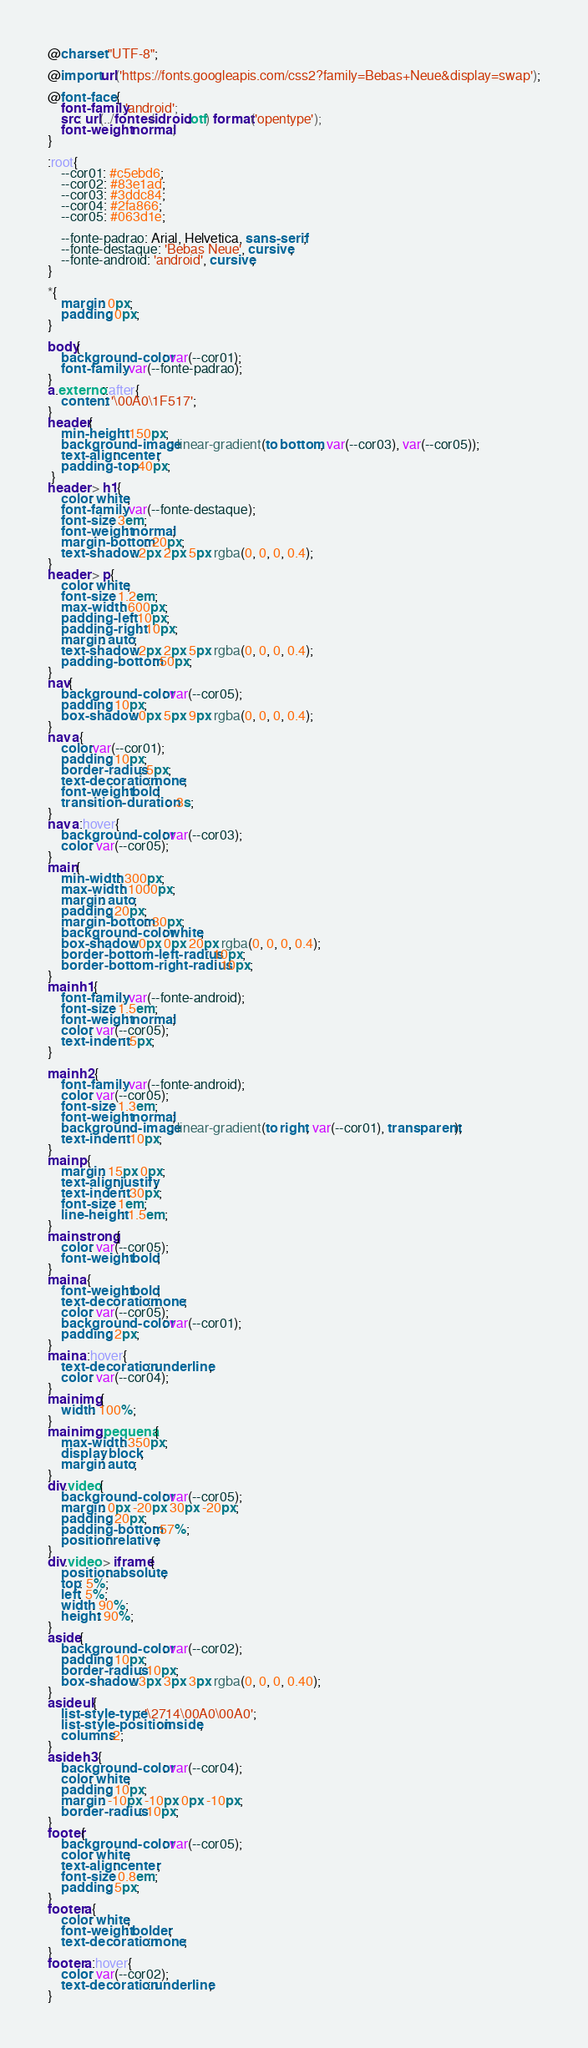Convert code to text. <code><loc_0><loc_0><loc_500><loc_500><_CSS_>@charset "UTF-8";
    
@import url('https://fonts.googleapis.com/css2?family=Bebas+Neue&display=swap');

@font-face {
    font-family:'android';
    src: url(../fontes/idroid.otf) format('opentype');
    font-weight: normal;   
}

:root{
    --cor01: #c5ebd6;
    --cor02: #83e1ad;
    --cor03: #3ddc84;
    --cor04: #2fa866;
    --cor05: #063d1e;

    --fonte-padrao: Arial, Helvetica, sans-serif; 
    --fonte-destaque: 'Bebas Neue', cursive;
    --fonte-android: 'android', cursive;
}

*{
    margin: 0px;
    padding: 0px;
}

body{
    background-color: var(--cor01);
    font-family: var(--fonte-padrao);   
}
a.externo::after{
    content: '\00A0\1F517';
}
header{
    min-height: 150px;    
    background-image: linear-gradient(to bottom, var(--cor03), var(--cor05)); 
    text-align: center;
    padding-top: 40px;
 }
header > h1{
    color: white;
    font-family: var(--fonte-destaque);
    font-size: 3em;
    font-weight: normal;
    margin-bottom: 20px;
    text-shadow: 2px 2px 5px rgba(0, 0, 0, 0.4);    
}
header > p{
    color: white;
    font-size: 1.2em;
    max-width: 600px;
    padding-left: 10px;
    padding-right: 10px;
    margin: auto;
    text-shadow: 2px 2px 5px rgba(0, 0, 0, 0.4);
    padding-bottom: 50px;
}
nav{
    background-color: var(--cor05);
    padding: 10px;
    box-shadow: 0px 5px 9px rgba(0, 0, 0, 0.4);
}
nav a{
    color:var(--cor01);
    padding: 10px;
    border-radius: 5px;
    text-decoration: none;
    font-weight: bold;
    transition-duration: .3s;
}
nav a:hover{
    background-color: var(--cor03);
    color: var(--cor05);
}
main{
    min-width: 300px;
    max-width: 1000px;
    margin: auto;
    padding: 20px;
    margin-bottom: 30px;
    background-color: white;
    box-shadow: 0px 0px 20px rgba(0, 0, 0, 0.4);
    border-bottom-left-radius: 10px;
    border-bottom-right-radius: 10px;
}
main h1{
    font-family: var(--fonte-android);
    font-size: 1.5em;
    font-weight: normal;
    color: var(--cor05);
    text-indent: 5px;
}

main h2{
    font-family: var(--fonte-android);
    color: var(--cor05);
    font-size: 1.3em;
    font-weight: normal;
    background-image: linear-gradient(to right, var(--cor01), transparent);
    text-indent: 10px;
}
main p{
    margin: 15px 0px;
    text-align: justify;
    text-indent: 30px;
    font-size: 1em;
    line-height: 1.5em;
}
main strong{
    color: var(--cor05);
    font-weight: bold;  
}
main a{
    font-weight: bold;
    text-decoration: none;
    color: var(--cor05);
    background-color: var(--cor01);
    padding: 2px;
}
main a:hover{
    text-decoration: underline;
    color: var(--cor04);
}
main img{
    width: 100%;
}
main img.pequena{
    max-width: 350px;
    display: block;
    margin: auto;
}
div.video{
    background-color: var(--cor05);
    margin: 0px -20px 30px -20px;
    padding: 20px;
    padding-bottom: 57%;
    position: relative;
}
div.video > iframe{
    position: absolute;
    top: 5%;
    left: 5%;
    width: 90%;
    height: 90%;
}
aside{
    background-color: var(--cor02);
    padding: 10px;
    border-radius: 10px;
    box-shadow: 3px 3px 3px rgba(0, 0, 0, 0.40);
}
aside ul{
    list-style-type: '\2714\00A0\00A0';
    list-style-position: inside;
    columns:2;
}
aside h3{
    background-color: var(--cor04);
    color: white;
    padding: 10px;
    margin: -10px -10px 0px -10px;
    border-radius: 10px;
}
footer{
    background-color: var(--cor05);
    color: white;
    text-align: center;
    font-size: 0.8em;
    padding: 5px;
}
footer a{
    color: white;
    font-weight: bolder;
    text-decoration: none;
}
footer a:hover{
    color: var(--cor02);
    text-decoration: underline;
}

</code> 